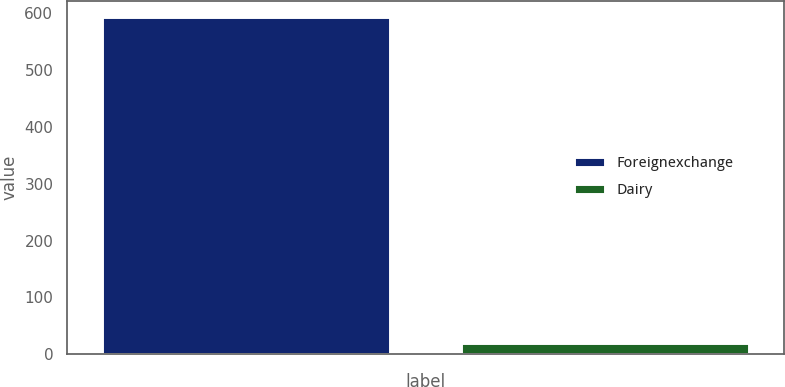Convert chart to OTSL. <chart><loc_0><loc_0><loc_500><loc_500><bar_chart><fcel>Foreignexchange<fcel>Dairy<nl><fcel>593<fcel>20<nl></chart> 